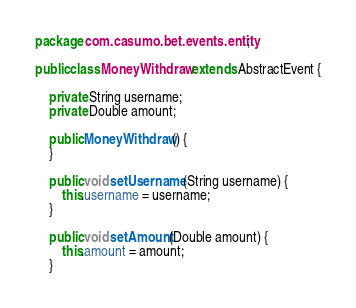<code> <loc_0><loc_0><loc_500><loc_500><_Java_>package com.casumo.bet.events.entity;

public class MoneyWithdraw extends AbstractEvent {

    private String username;
    private Double amount;

    public MoneyWithdraw() {
    }

    public void setUsername(String username) {
        this.username = username;
    }

    public void setAmount(Double amount) {
        this.amount = amount;
    }
</code> 